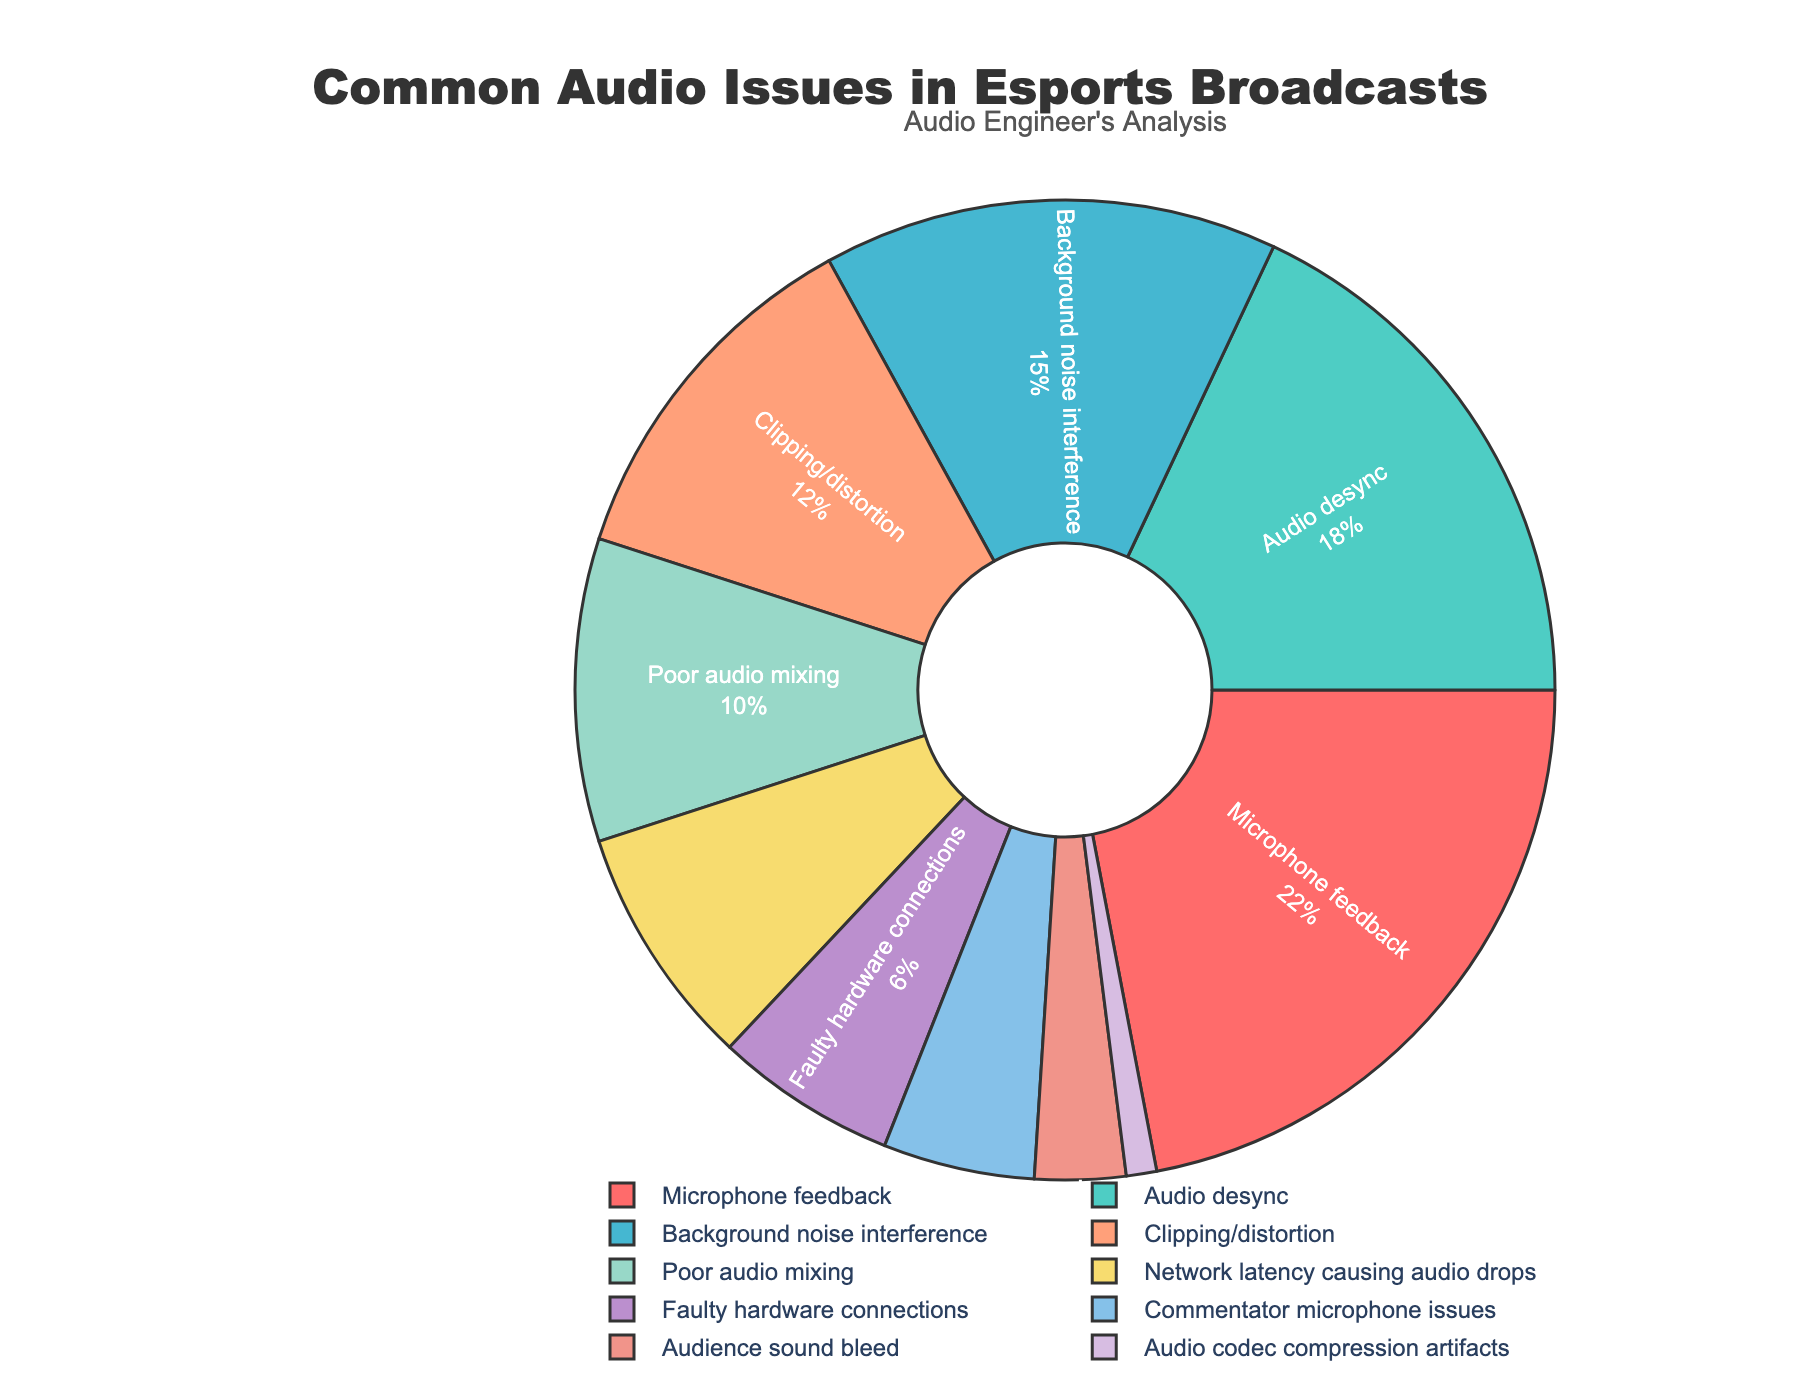Which issue has the highest percentage? The segment labeled "Microphone feedback" is the largest in the pie chart. The label shows it occupies 22% of the total.
Answer: Microphone feedback What is the combined percentage of "Background noise interference" and "Clipping/distortion"? "Background noise interference" has a percentage of 15% and "Clipping/distortion" has 12%. Adding them together, 15% + 12% = 27%.
Answer: 27% Are there more "Audio desync" issues or "Poor audio mixing" issues? "Audio desync" issues have a percentage of 18%, whereas "Poor audio mixing" has a percentage of 10%. 18% is greater than 10%, so "Audio desync" issues are more common.
Answer: Audio desync What is the total percentage of issues related to hardware (Faulty hardware connections and Network latency causing audio drops)? "Faulty hardware connections" account for 6% and "Network latency causing audio drops" account for 8%. Summing them, 6% + 8% = 14%.
Answer: 14% Which issue represents the smallest percentage? The segment labeled "Audio codec compression artifacts" is the smallest in the pie chart, indicated as 1%.
Answer: Audio codec compression artifacts Compare the percentages of "Commentator microphone issues" and "Audience sound bleed". Which one is higher and by how much? "Commentator microphone issues" have a percentage of 5% and "Audience sound bleed" is at 3%. The difference is 5% - 3% = 2%. Thus, "Commentator microphone issues" is higher by 2%.
Answer: Commentator microphone issues by 2% What percentage of issues fall under 10%? The segments for "Network latency causing audio drops" (8%), "Faulty hardware connections" (6%), "Commentator microphone issues" (5%), "Audience sound bleed" (3%), and "Audio codec compression artifacts" (1%) are all under 10%. Adding them, we get 8% + 6% + 5% + 3% + 1% = 23%.
Answer: 23% Which audio issue is represented by the blue segment in the pie chart? The pie chart has various colors assigned to different issues. The label associated with the blue segment is "Audio desync", which represents 18%.
Answer: Audio desync How much more prevalent is "Microphone feedback" compared to "Faulty hardware connections"? "Microphone feedback" (22%) is compared to "Faulty hardware connections" (6%). The difference is 22% - 6% = 16%.
Answer: 16% What is the ratio of "Audio desync" to "Poor audio mixing"? "Audio desync" has 18% and "Poor audio mixing" has 10%. The ratio is 18% / 10%, which simplifies to 1.8 or 9:5.
Answer: 1.8 or 9:5 